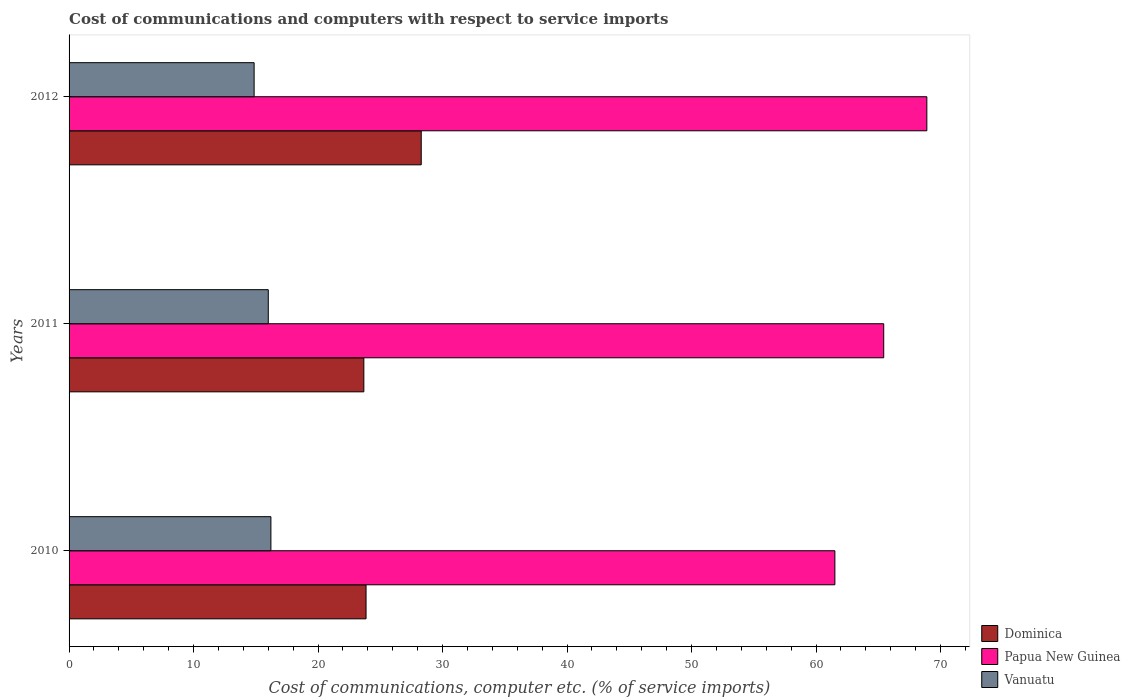How many groups of bars are there?
Offer a terse response. 3. Are the number of bars on each tick of the Y-axis equal?
Give a very brief answer. Yes. How many bars are there on the 3rd tick from the top?
Your answer should be compact. 3. How many bars are there on the 1st tick from the bottom?
Provide a short and direct response. 3. What is the label of the 3rd group of bars from the top?
Make the answer very short. 2010. In how many cases, is the number of bars for a given year not equal to the number of legend labels?
Ensure brevity in your answer.  0. What is the cost of communications and computers in Dominica in 2011?
Ensure brevity in your answer.  23.68. Across all years, what is the maximum cost of communications and computers in Papua New Guinea?
Give a very brief answer. 68.9. Across all years, what is the minimum cost of communications and computers in Vanuatu?
Your answer should be compact. 14.87. In which year was the cost of communications and computers in Vanuatu maximum?
Offer a very short reply. 2010. What is the total cost of communications and computers in Papua New Guinea in the graph?
Your answer should be very brief. 195.86. What is the difference between the cost of communications and computers in Papua New Guinea in 2010 and that in 2011?
Your answer should be compact. -3.92. What is the difference between the cost of communications and computers in Papua New Guinea in 2010 and the cost of communications and computers in Vanuatu in 2012?
Provide a short and direct response. 46.65. What is the average cost of communications and computers in Dominica per year?
Offer a very short reply. 25.27. In the year 2012, what is the difference between the cost of communications and computers in Dominica and cost of communications and computers in Vanuatu?
Make the answer very short. 13.42. In how many years, is the cost of communications and computers in Papua New Guinea greater than 16 %?
Provide a short and direct response. 3. What is the ratio of the cost of communications and computers in Papua New Guinea in 2011 to that in 2012?
Keep it short and to the point. 0.95. Is the difference between the cost of communications and computers in Dominica in 2010 and 2011 greater than the difference between the cost of communications and computers in Vanuatu in 2010 and 2011?
Provide a short and direct response. No. What is the difference between the highest and the second highest cost of communications and computers in Papua New Guinea?
Make the answer very short. 3.46. What is the difference between the highest and the lowest cost of communications and computers in Papua New Guinea?
Your response must be concise. 7.39. Is the sum of the cost of communications and computers in Vanuatu in 2010 and 2012 greater than the maximum cost of communications and computers in Dominica across all years?
Keep it short and to the point. Yes. What does the 1st bar from the top in 2010 represents?
Offer a terse response. Vanuatu. What does the 3rd bar from the bottom in 2011 represents?
Ensure brevity in your answer.  Vanuatu. Are the values on the major ticks of X-axis written in scientific E-notation?
Ensure brevity in your answer.  No. Does the graph contain grids?
Provide a succinct answer. No. What is the title of the graph?
Provide a succinct answer. Cost of communications and computers with respect to service imports. What is the label or title of the X-axis?
Your response must be concise. Cost of communications, computer etc. (% of service imports). What is the Cost of communications, computer etc. (% of service imports) of Dominica in 2010?
Keep it short and to the point. 23.86. What is the Cost of communications, computer etc. (% of service imports) in Papua New Guinea in 2010?
Your response must be concise. 61.52. What is the Cost of communications, computer etc. (% of service imports) in Vanuatu in 2010?
Your answer should be very brief. 16.21. What is the Cost of communications, computer etc. (% of service imports) of Dominica in 2011?
Offer a very short reply. 23.68. What is the Cost of communications, computer etc. (% of service imports) of Papua New Guinea in 2011?
Give a very brief answer. 65.44. What is the Cost of communications, computer etc. (% of service imports) of Vanuatu in 2011?
Offer a very short reply. 16. What is the Cost of communications, computer etc. (% of service imports) in Dominica in 2012?
Provide a succinct answer. 28.29. What is the Cost of communications, computer etc. (% of service imports) in Papua New Guinea in 2012?
Your response must be concise. 68.9. What is the Cost of communications, computer etc. (% of service imports) of Vanuatu in 2012?
Make the answer very short. 14.87. Across all years, what is the maximum Cost of communications, computer etc. (% of service imports) of Dominica?
Your response must be concise. 28.29. Across all years, what is the maximum Cost of communications, computer etc. (% of service imports) of Papua New Guinea?
Keep it short and to the point. 68.9. Across all years, what is the maximum Cost of communications, computer etc. (% of service imports) in Vanuatu?
Provide a succinct answer. 16.21. Across all years, what is the minimum Cost of communications, computer etc. (% of service imports) of Dominica?
Make the answer very short. 23.68. Across all years, what is the minimum Cost of communications, computer etc. (% of service imports) of Papua New Guinea?
Give a very brief answer. 61.52. Across all years, what is the minimum Cost of communications, computer etc. (% of service imports) of Vanuatu?
Provide a succinct answer. 14.87. What is the total Cost of communications, computer etc. (% of service imports) of Dominica in the graph?
Your response must be concise. 75.82. What is the total Cost of communications, computer etc. (% of service imports) of Papua New Guinea in the graph?
Give a very brief answer. 195.86. What is the total Cost of communications, computer etc. (% of service imports) of Vanuatu in the graph?
Ensure brevity in your answer.  47.08. What is the difference between the Cost of communications, computer etc. (% of service imports) in Dominica in 2010 and that in 2011?
Your answer should be very brief. 0.18. What is the difference between the Cost of communications, computer etc. (% of service imports) of Papua New Guinea in 2010 and that in 2011?
Offer a terse response. -3.92. What is the difference between the Cost of communications, computer etc. (% of service imports) in Vanuatu in 2010 and that in 2011?
Make the answer very short. 0.21. What is the difference between the Cost of communications, computer etc. (% of service imports) of Dominica in 2010 and that in 2012?
Your response must be concise. -4.43. What is the difference between the Cost of communications, computer etc. (% of service imports) of Papua New Guinea in 2010 and that in 2012?
Provide a succinct answer. -7.39. What is the difference between the Cost of communications, computer etc. (% of service imports) of Vanuatu in 2010 and that in 2012?
Your answer should be very brief. 1.35. What is the difference between the Cost of communications, computer etc. (% of service imports) of Dominica in 2011 and that in 2012?
Your answer should be compact. -4.61. What is the difference between the Cost of communications, computer etc. (% of service imports) in Papua New Guinea in 2011 and that in 2012?
Provide a succinct answer. -3.46. What is the difference between the Cost of communications, computer etc. (% of service imports) in Vanuatu in 2011 and that in 2012?
Your answer should be very brief. 1.14. What is the difference between the Cost of communications, computer etc. (% of service imports) of Dominica in 2010 and the Cost of communications, computer etc. (% of service imports) of Papua New Guinea in 2011?
Offer a terse response. -41.58. What is the difference between the Cost of communications, computer etc. (% of service imports) in Dominica in 2010 and the Cost of communications, computer etc. (% of service imports) in Vanuatu in 2011?
Give a very brief answer. 7.85. What is the difference between the Cost of communications, computer etc. (% of service imports) of Papua New Guinea in 2010 and the Cost of communications, computer etc. (% of service imports) of Vanuatu in 2011?
Your answer should be very brief. 45.51. What is the difference between the Cost of communications, computer etc. (% of service imports) in Dominica in 2010 and the Cost of communications, computer etc. (% of service imports) in Papua New Guinea in 2012?
Provide a short and direct response. -45.05. What is the difference between the Cost of communications, computer etc. (% of service imports) in Dominica in 2010 and the Cost of communications, computer etc. (% of service imports) in Vanuatu in 2012?
Offer a very short reply. 8.99. What is the difference between the Cost of communications, computer etc. (% of service imports) of Papua New Guinea in 2010 and the Cost of communications, computer etc. (% of service imports) of Vanuatu in 2012?
Your response must be concise. 46.65. What is the difference between the Cost of communications, computer etc. (% of service imports) in Dominica in 2011 and the Cost of communications, computer etc. (% of service imports) in Papua New Guinea in 2012?
Make the answer very short. -45.23. What is the difference between the Cost of communications, computer etc. (% of service imports) of Dominica in 2011 and the Cost of communications, computer etc. (% of service imports) of Vanuatu in 2012?
Your answer should be compact. 8.81. What is the difference between the Cost of communications, computer etc. (% of service imports) of Papua New Guinea in 2011 and the Cost of communications, computer etc. (% of service imports) of Vanuatu in 2012?
Ensure brevity in your answer.  50.57. What is the average Cost of communications, computer etc. (% of service imports) of Dominica per year?
Offer a very short reply. 25.27. What is the average Cost of communications, computer etc. (% of service imports) of Papua New Guinea per year?
Provide a short and direct response. 65.29. What is the average Cost of communications, computer etc. (% of service imports) of Vanuatu per year?
Your answer should be very brief. 15.69. In the year 2010, what is the difference between the Cost of communications, computer etc. (% of service imports) in Dominica and Cost of communications, computer etc. (% of service imports) in Papua New Guinea?
Your response must be concise. -37.66. In the year 2010, what is the difference between the Cost of communications, computer etc. (% of service imports) in Dominica and Cost of communications, computer etc. (% of service imports) in Vanuatu?
Provide a succinct answer. 7.64. In the year 2010, what is the difference between the Cost of communications, computer etc. (% of service imports) of Papua New Guinea and Cost of communications, computer etc. (% of service imports) of Vanuatu?
Offer a terse response. 45.3. In the year 2011, what is the difference between the Cost of communications, computer etc. (% of service imports) in Dominica and Cost of communications, computer etc. (% of service imports) in Papua New Guinea?
Provide a succinct answer. -41.76. In the year 2011, what is the difference between the Cost of communications, computer etc. (% of service imports) of Dominica and Cost of communications, computer etc. (% of service imports) of Vanuatu?
Your answer should be compact. 7.68. In the year 2011, what is the difference between the Cost of communications, computer etc. (% of service imports) of Papua New Guinea and Cost of communications, computer etc. (% of service imports) of Vanuatu?
Make the answer very short. 49.44. In the year 2012, what is the difference between the Cost of communications, computer etc. (% of service imports) of Dominica and Cost of communications, computer etc. (% of service imports) of Papua New Guinea?
Offer a terse response. -40.61. In the year 2012, what is the difference between the Cost of communications, computer etc. (% of service imports) of Dominica and Cost of communications, computer etc. (% of service imports) of Vanuatu?
Provide a short and direct response. 13.42. In the year 2012, what is the difference between the Cost of communications, computer etc. (% of service imports) in Papua New Guinea and Cost of communications, computer etc. (% of service imports) in Vanuatu?
Provide a short and direct response. 54.04. What is the ratio of the Cost of communications, computer etc. (% of service imports) in Dominica in 2010 to that in 2011?
Your answer should be compact. 1.01. What is the ratio of the Cost of communications, computer etc. (% of service imports) of Papua New Guinea in 2010 to that in 2011?
Your answer should be compact. 0.94. What is the ratio of the Cost of communications, computer etc. (% of service imports) in Vanuatu in 2010 to that in 2011?
Your response must be concise. 1.01. What is the ratio of the Cost of communications, computer etc. (% of service imports) in Dominica in 2010 to that in 2012?
Make the answer very short. 0.84. What is the ratio of the Cost of communications, computer etc. (% of service imports) of Papua New Guinea in 2010 to that in 2012?
Provide a succinct answer. 0.89. What is the ratio of the Cost of communications, computer etc. (% of service imports) of Vanuatu in 2010 to that in 2012?
Your answer should be compact. 1.09. What is the ratio of the Cost of communications, computer etc. (% of service imports) of Dominica in 2011 to that in 2012?
Offer a very short reply. 0.84. What is the ratio of the Cost of communications, computer etc. (% of service imports) of Papua New Guinea in 2011 to that in 2012?
Your answer should be very brief. 0.95. What is the ratio of the Cost of communications, computer etc. (% of service imports) in Vanuatu in 2011 to that in 2012?
Your answer should be compact. 1.08. What is the difference between the highest and the second highest Cost of communications, computer etc. (% of service imports) in Dominica?
Offer a very short reply. 4.43. What is the difference between the highest and the second highest Cost of communications, computer etc. (% of service imports) in Papua New Guinea?
Provide a succinct answer. 3.46. What is the difference between the highest and the second highest Cost of communications, computer etc. (% of service imports) of Vanuatu?
Your answer should be very brief. 0.21. What is the difference between the highest and the lowest Cost of communications, computer etc. (% of service imports) of Dominica?
Your response must be concise. 4.61. What is the difference between the highest and the lowest Cost of communications, computer etc. (% of service imports) of Papua New Guinea?
Offer a terse response. 7.39. What is the difference between the highest and the lowest Cost of communications, computer etc. (% of service imports) of Vanuatu?
Provide a succinct answer. 1.35. 